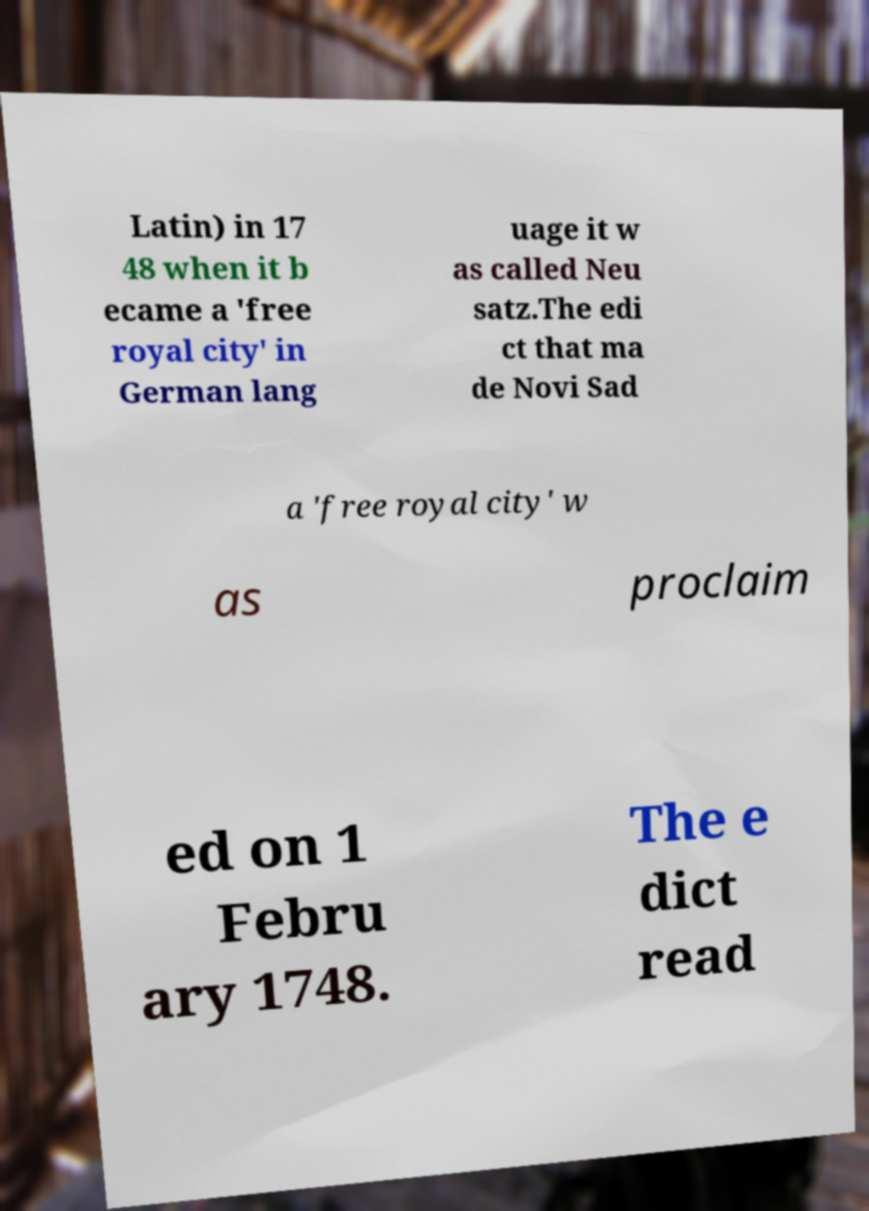There's text embedded in this image that I need extracted. Can you transcribe it verbatim? Latin) in 17 48 when it b ecame a 'free royal city' in German lang uage it w as called Neu satz.The edi ct that ma de Novi Sad a 'free royal city' w as proclaim ed on 1 Febru ary 1748. The e dict read 